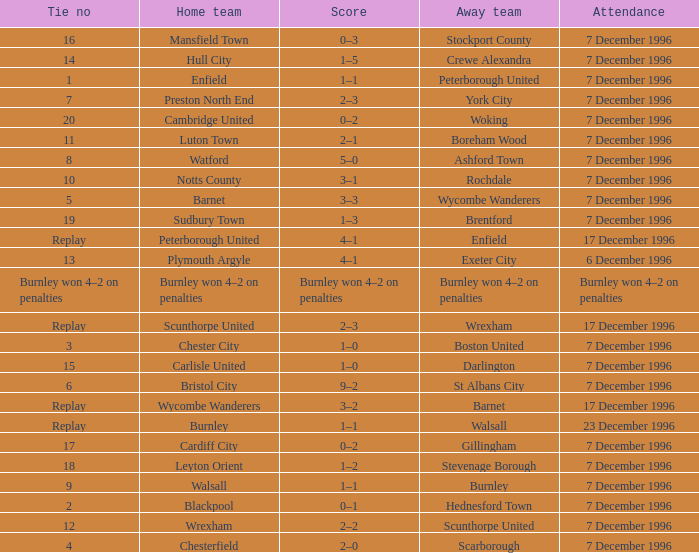What was the attendance for the home team of Walsall? 7 December 1996. 